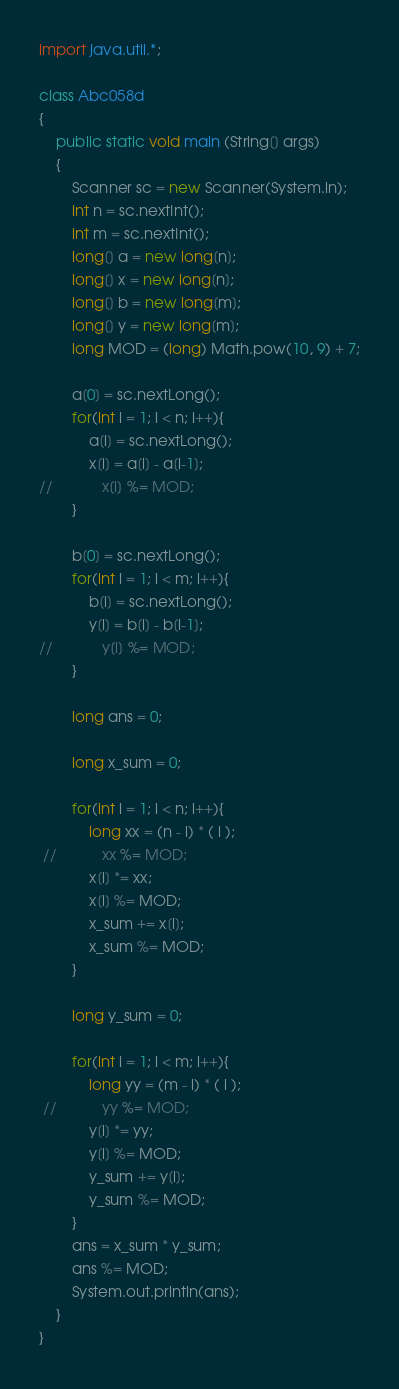<code> <loc_0><loc_0><loc_500><loc_500><_Java_>import java.util.*;

class Abc058d
{
    public static void main (String[] args)
    {
        Scanner sc = new Scanner(System.in);
        int n = sc.nextInt();
        int m = sc.nextInt();
        long[] a = new long[n];
        long[] x = new long[n];
        long[] b = new long[m];
        long[] y = new long[m];
        long MOD = (long) Math.pow(10, 9) + 7;

        a[0] = sc.nextLong();
        for(int i = 1; i < n; i++){
            a[i] = sc.nextLong();
            x[i] = a[i] - a[i-1];
//            x[i] %= MOD;
        }

        b[0] = sc.nextLong();
        for(int i = 1; i < m; i++){
            b[i] = sc.nextLong();
            y[i] = b[i] - b[i-1];
//            y[i] %= MOD;
        }

        long ans = 0;

        long x_sum = 0;

        for(int i = 1; i < n; i++){
            long xx = (n - i) * ( i );    
 //           xx %= MOD;
            x[i] *= xx;
            x[i] %= MOD;
            x_sum += x[i];
            x_sum %= MOD;
        }

        long y_sum = 0;

        for(int i = 1; i < m; i++){
            long yy = (m - i) * ( i );    
 //           yy %= MOD;
            y[i] *= yy;
            y[i] %= MOD;
            y_sum += y[i];
            y_sum %= MOD;
        }
        ans = x_sum * y_sum;
        ans %= MOD;
        System.out.println(ans);
    }
}</code> 